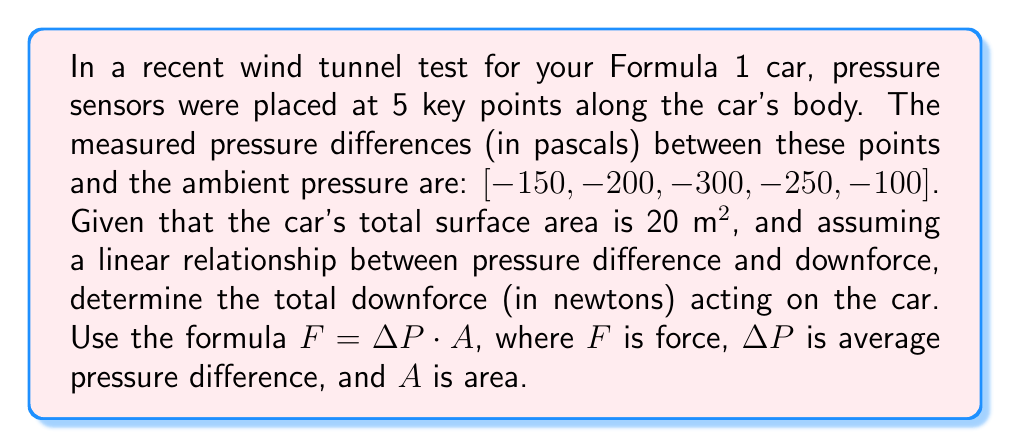Can you answer this question? To solve this problem, we'll follow these steps:

1) Calculate the average pressure difference:
   $$\Delta P_{avg} = \frac{-150 + (-200) + (-300) + (-250) + (-100)}{5} = -200 \text{ Pa}$$

2) Use the given formula $F = \Delta P \cdot A$ to calculate the total downforce:
   $$F = -200 \text{ Pa} \cdot 20 \text{ m}^2$$

3) Multiply the values:
   $$F = -4000 \text{ N}$$

4) The negative sign indicates that the force is acting downwards (downforce). We'll express the final answer as a positive value for clarity.
Answer: 4000 N 